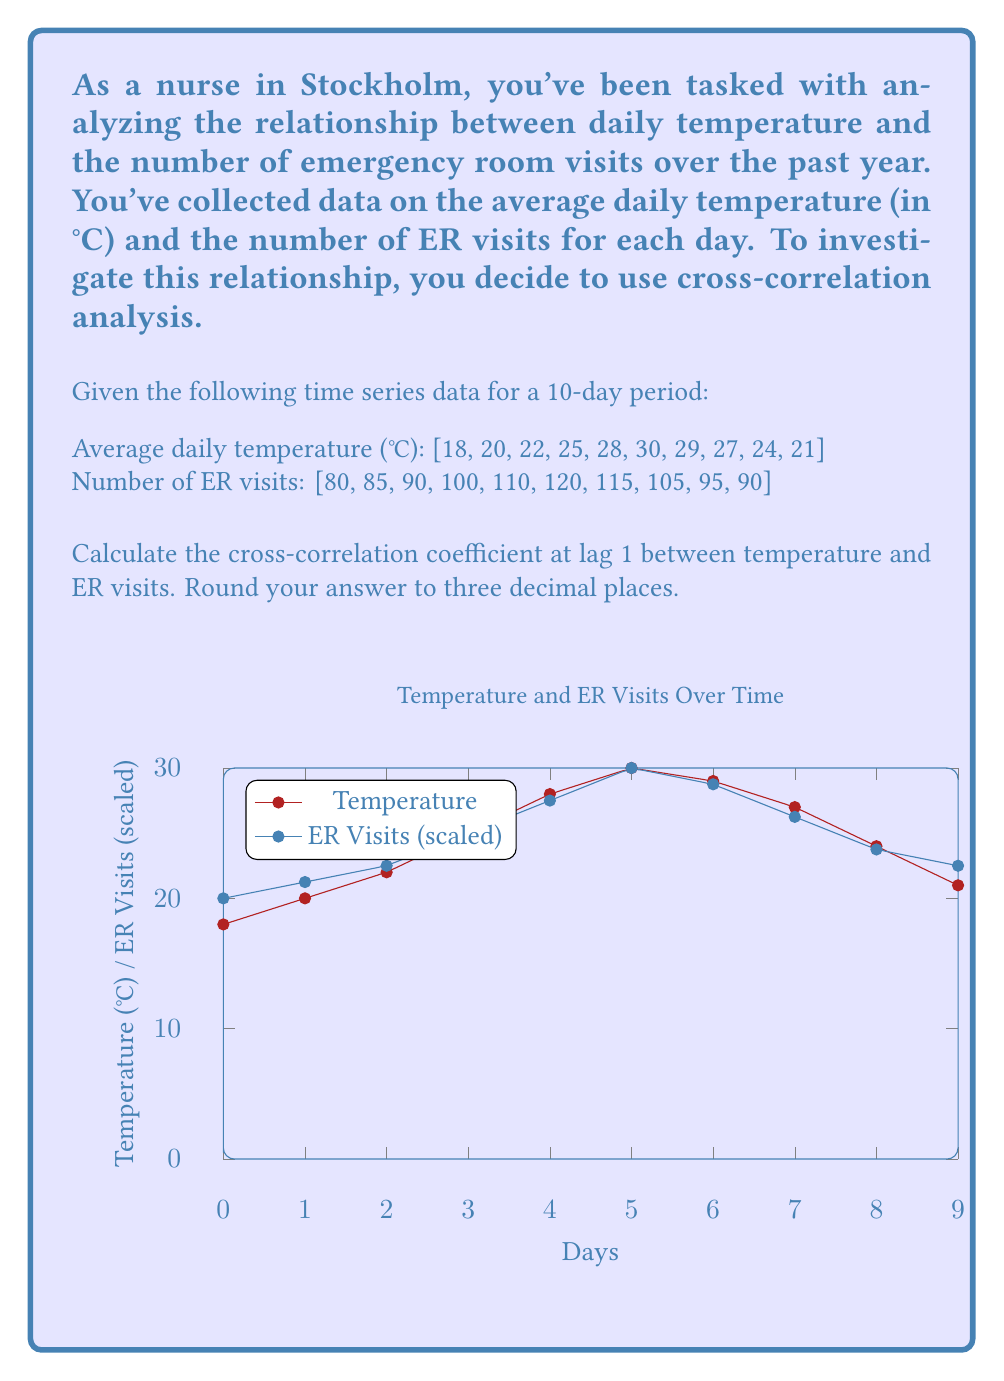Could you help me with this problem? To calculate the cross-correlation coefficient at lag 1, we'll follow these steps:

1) First, we need to calculate the means of both series:

   $\bar{T} = \frac{18 + 20 + 22 + 25 + 28 + 30 + 29 + 27 + 24 + 21}{10} = 24.4$
   $\bar{V} = \frac{80 + 85 + 90 + 100 + 110 + 120 + 115 + 105 + 95 + 90}{10} = 99$

2) Next, we calculate the deviations from the mean for each series:

   Temperature deviations: [-6.4, -4.4, -2.4, 0.6, 3.6, 5.6, 4.6, 2.6, -0.4, -3.4]
   ER visits deviations: [-19, -14, -9, 1, 11, 21, 16, 6, -4, -9]

3) For lag 1, we shift the ER visits series by one day and pair it with the temperature series:

   Temperature: [-6.4, -4.4, -2.4, 0.6, 3.6, 5.6, 4.6, 2.6, -0.4]
   ER visits (shifted): [-14, -9, 1, 11, 21, 16, 6, -4, -9]

4) We calculate the cross-covariance:

   $C_{TV}(1) = \frac{1}{9} \sum_{t=1}^{9} (T_t - \bar{T})(V_{t+1} - \bar{V})$

   $C_{TV}(1) = \frac{1}{9}[(-6.4 \times -14) + (-4.4 \times -9) + ... + (-0.4 \times -9)] = 22.6889$

5) We calculate the standard deviations of both series:

   $s_T = \sqrt{\frac{1}{10} \sum_{t=1}^{10} (T_t - \bar{T})^2} = 4.3012$
   $s_V = \sqrt{\frac{1}{10} \sum_{t=1}^{10} (V_t - \bar{V})^2} = 13.7840$

6) Finally, we calculate the cross-correlation coefficient:

   $r_{TV}(1) = \frac{C_{TV}(1)}{s_T s_V} = \frac{22.6889}{4.3012 \times 13.7840} = 0.3834$

Rounding to three decimal places, we get 0.383.
Answer: 0.383 